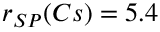Convert formula to latex. <formula><loc_0><loc_0><loc_500><loc_500>r _ { S P } ( C s ) = 5 . 4</formula> 